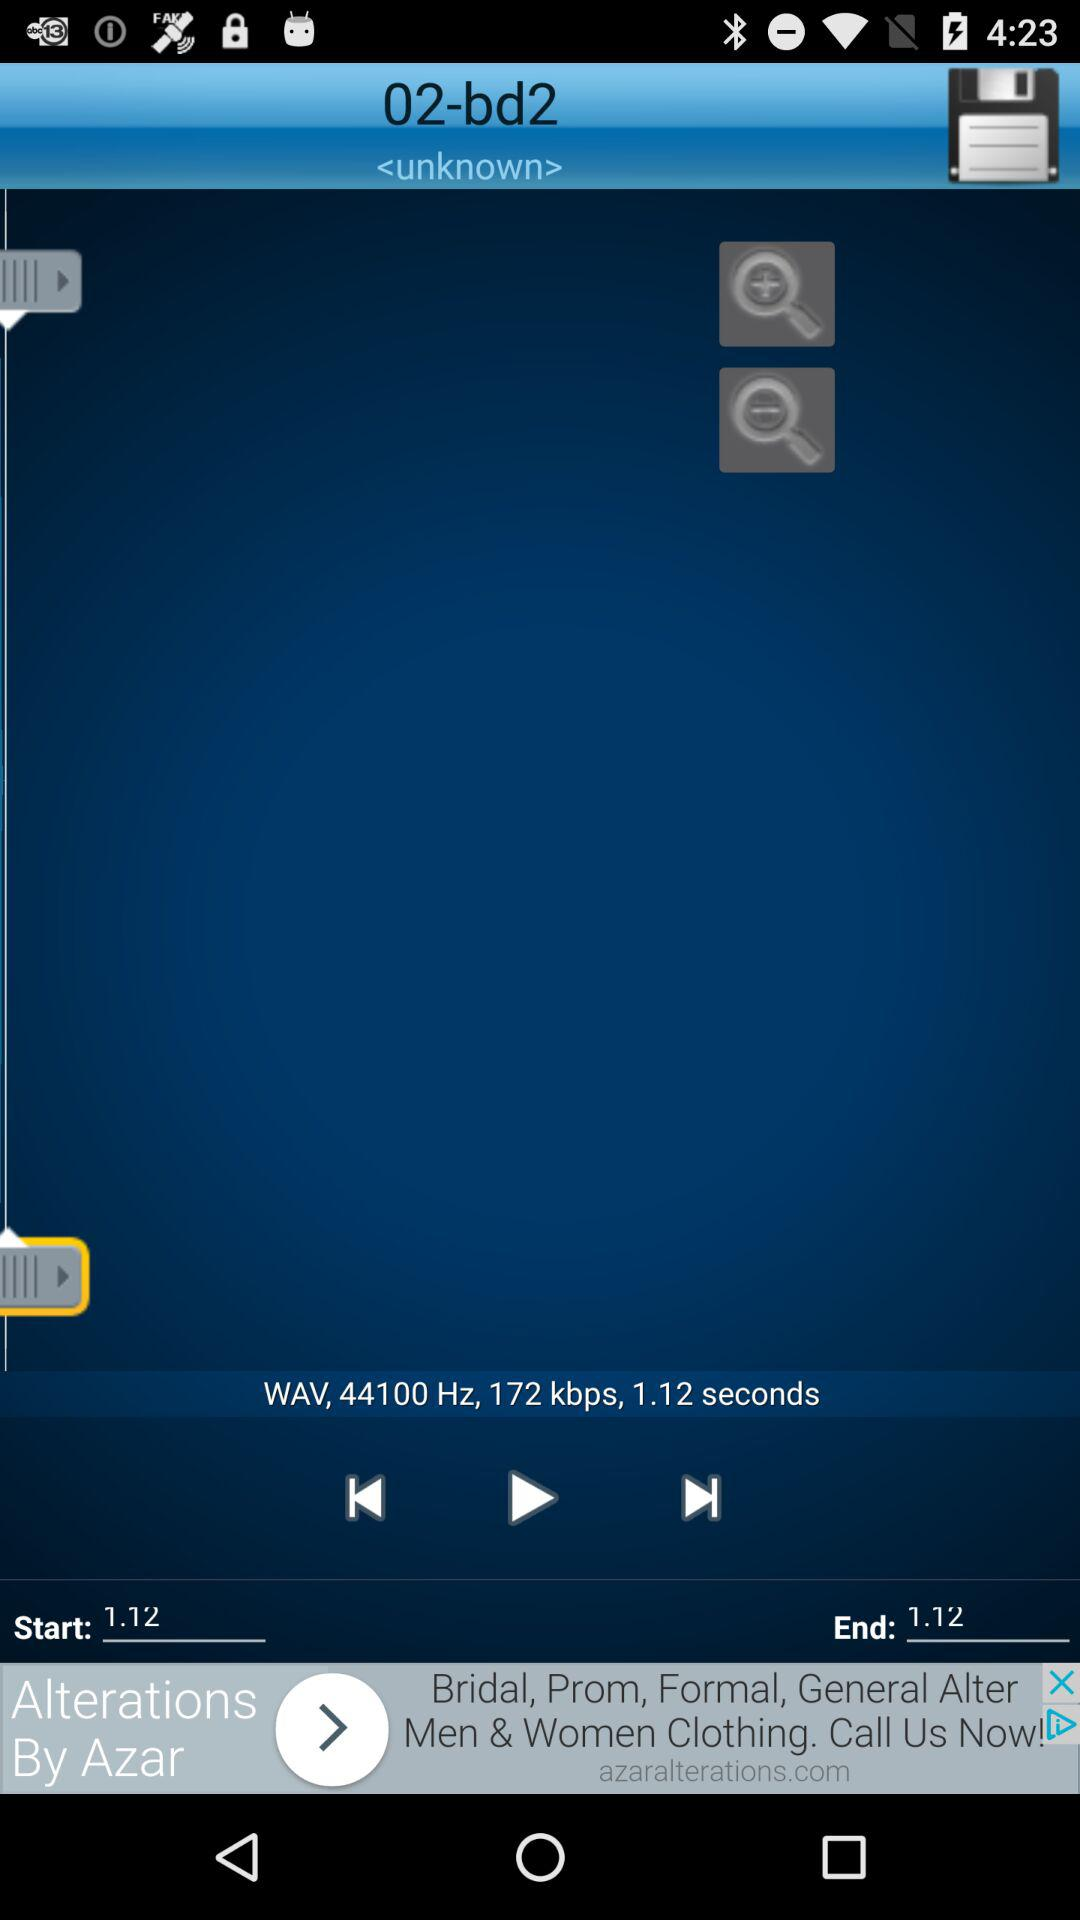How do you save the audio file?
When the provided information is insufficient, respond with <no answer>. <no answer> 